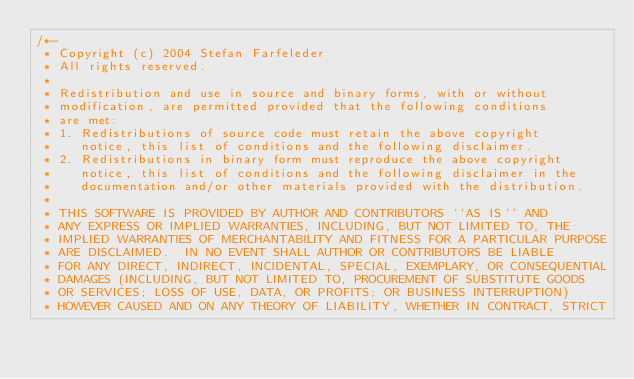Convert code to text. <code><loc_0><loc_0><loc_500><loc_500><_C_>/*-
 * Copyright (c) 2004 Stefan Farfeleder
 * All rights reserved.
 *
 * Redistribution and use in source and binary forms, with or without
 * modification, are permitted provided that the following conditions
 * are met:
 * 1. Redistributions of source code must retain the above copyright
 *    notice, this list of conditions and the following disclaimer.
 * 2. Redistributions in binary form must reproduce the above copyright
 *    notice, this list of conditions and the following disclaimer in the
 *    documentation and/or other materials provided with the distribution.
 *
 * THIS SOFTWARE IS PROVIDED BY AUTHOR AND CONTRIBUTORS ``AS IS'' AND
 * ANY EXPRESS OR IMPLIED WARRANTIES, INCLUDING, BUT NOT LIMITED TO, THE
 * IMPLIED WARRANTIES OF MERCHANTABILITY AND FITNESS FOR A PARTICULAR PURPOSE
 * ARE DISCLAIMED.  IN NO EVENT SHALL AUTHOR OR CONTRIBUTORS BE LIABLE
 * FOR ANY DIRECT, INDIRECT, INCIDENTAL, SPECIAL, EXEMPLARY, OR CONSEQUENTIAL
 * DAMAGES (INCLUDING, BUT NOT LIMITED TO, PROCUREMENT OF SUBSTITUTE GOODS
 * OR SERVICES; LOSS OF USE, DATA, OR PROFITS; OR BUSINESS INTERRUPTION)
 * HOWEVER CAUSED AND ON ANY THEORY OF LIABILITY, WHETHER IN CONTRACT, STRICT</code> 